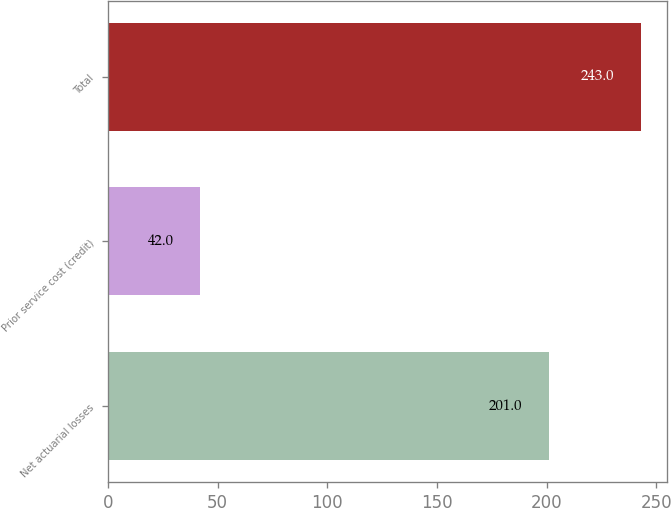Convert chart to OTSL. <chart><loc_0><loc_0><loc_500><loc_500><bar_chart><fcel>Net actuarial losses<fcel>Prior service cost (credit)<fcel>Total<nl><fcel>201<fcel>42<fcel>243<nl></chart> 